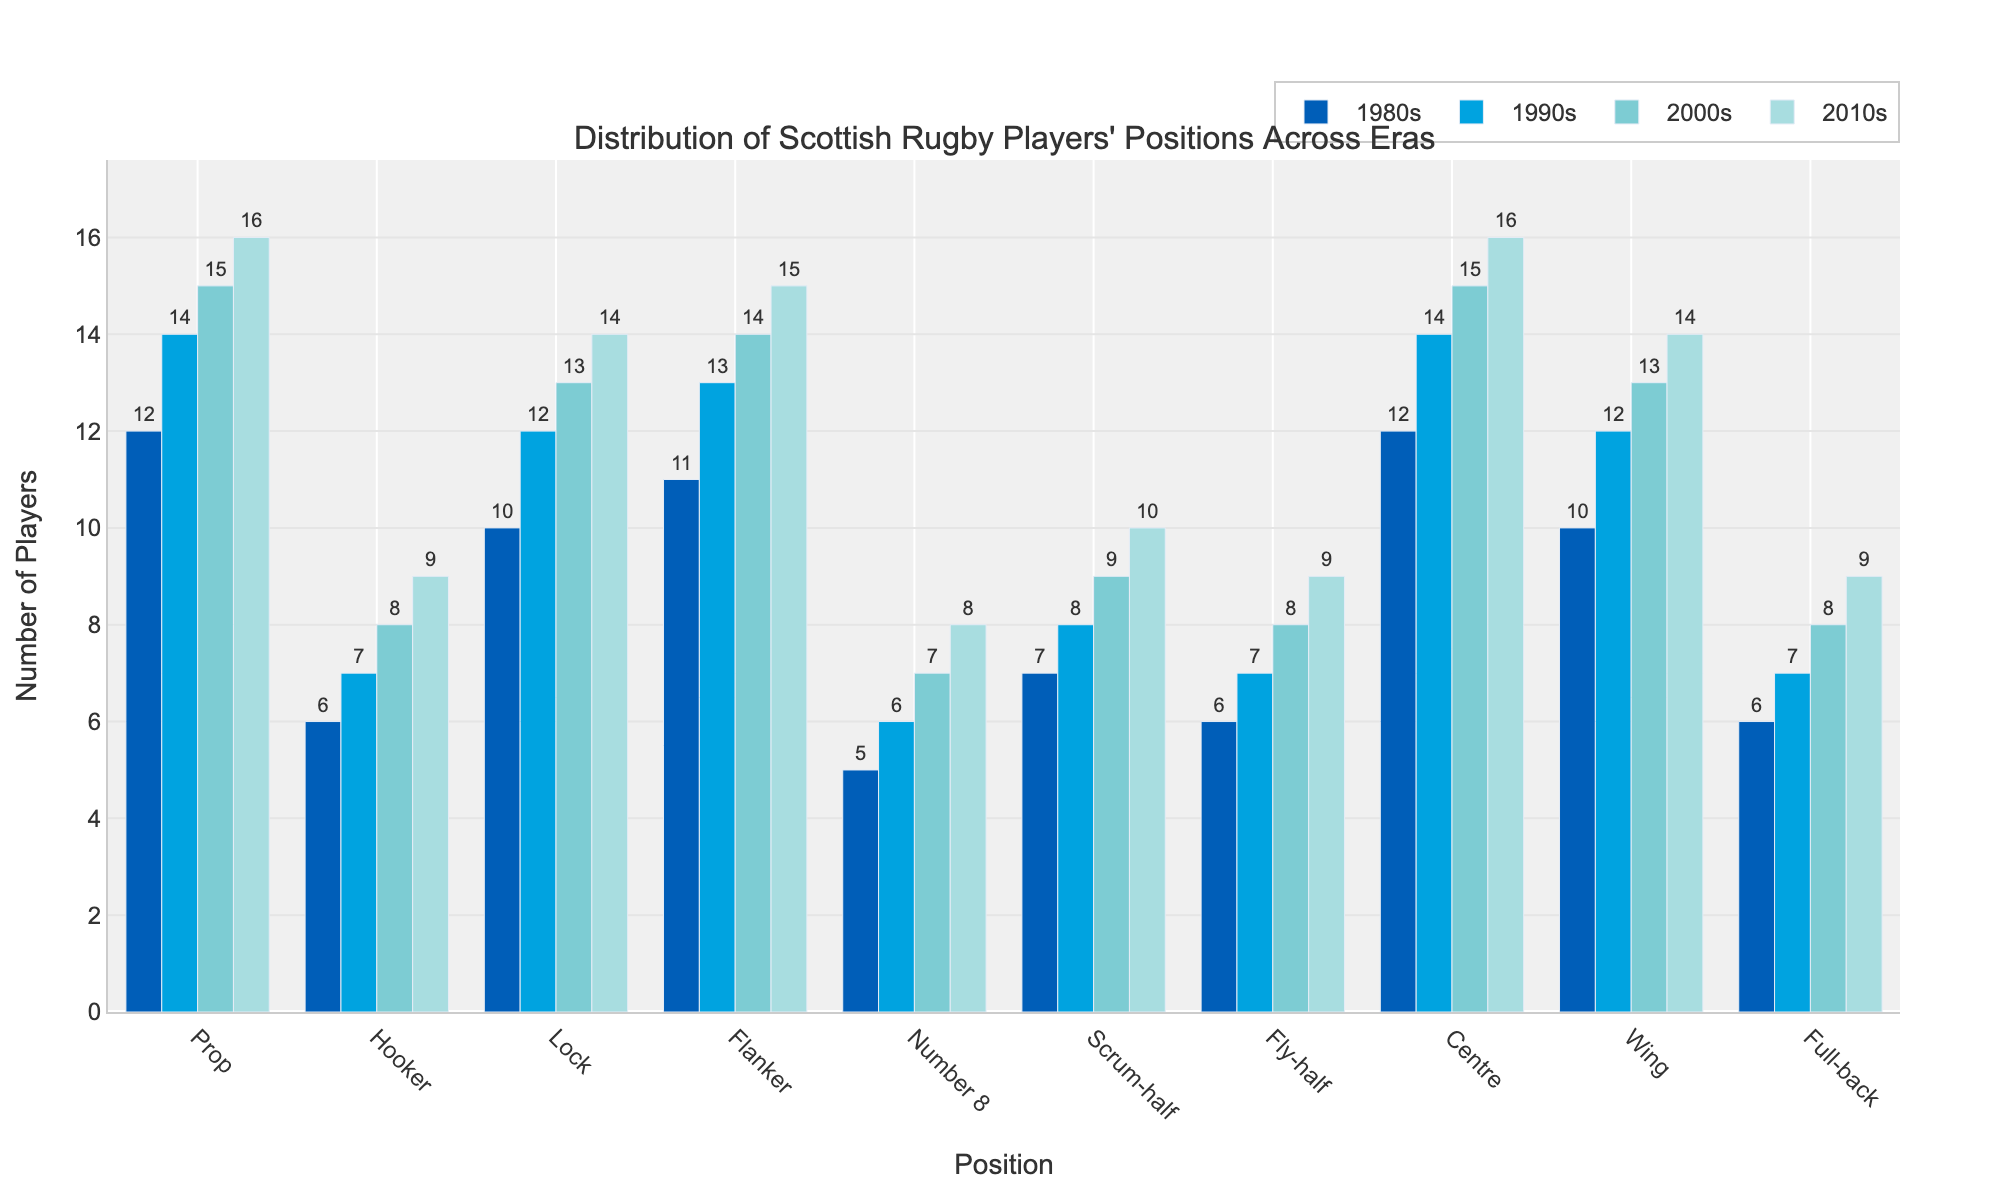Which position had the most players in the 2010s? Observe the height of the bars for each position in the 2010s category, the tallest bar corresponds to the Centre position.
Answer: Centre How did the number of Props change from the 1980s to the 2010s? Compare the bar heights for the Prop position across the decades and observe the increase from 12 in the 1980s to 16 in the 2010s.
Answer: Increased by 4 What is the sum of the number of Scrum-halves and Fly-halves in the 2000s? Add the numerical values for Scrum-halves (9) and Fly-halves (8) in the 2000s.
Answer: 17 Which decade saw the highest number of Full-backs? Observe the bar heights for Full-back across all decades and identify the decade with the tallest bar, the 2010s, with a value of 9.
Answer: 2010s Compare the number of players in the Lock position between the 1980s and the 1990s. Look at the numerical values for the Lock position in the 1980s (10) and the 1990s (12), and compare them.
Answer: The number increased by 2 What's the average number of Hookers across all decades? Sum the values for Hooker (6, 7, 8, 9) and divide by the number of decades (4), resulting in (6+7+8+9)/4 = 30/4 = 7.5.
Answer: 7.5 What is the difference between the number of Flankers in the 2000s and 2010s? Subtract the number of Flankers in the 2000s (14) from the number in the 2010s (15).
Answer: 1 Which player position consistently increased in number through the decades? Compare the values for each position across all decades and identify positions with increasing values. Both Prop and Centre show a consistent increase.
Answer: Prop, Centre For which positions did the number of players remain unchanged between two consecutive decades? Identify positions where the number of players in one decade is equal to the number of players in the following decade. No positions fit this criterion.
Answer: None 